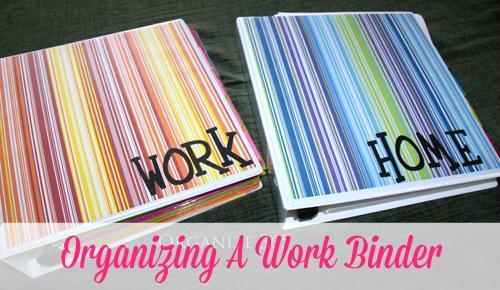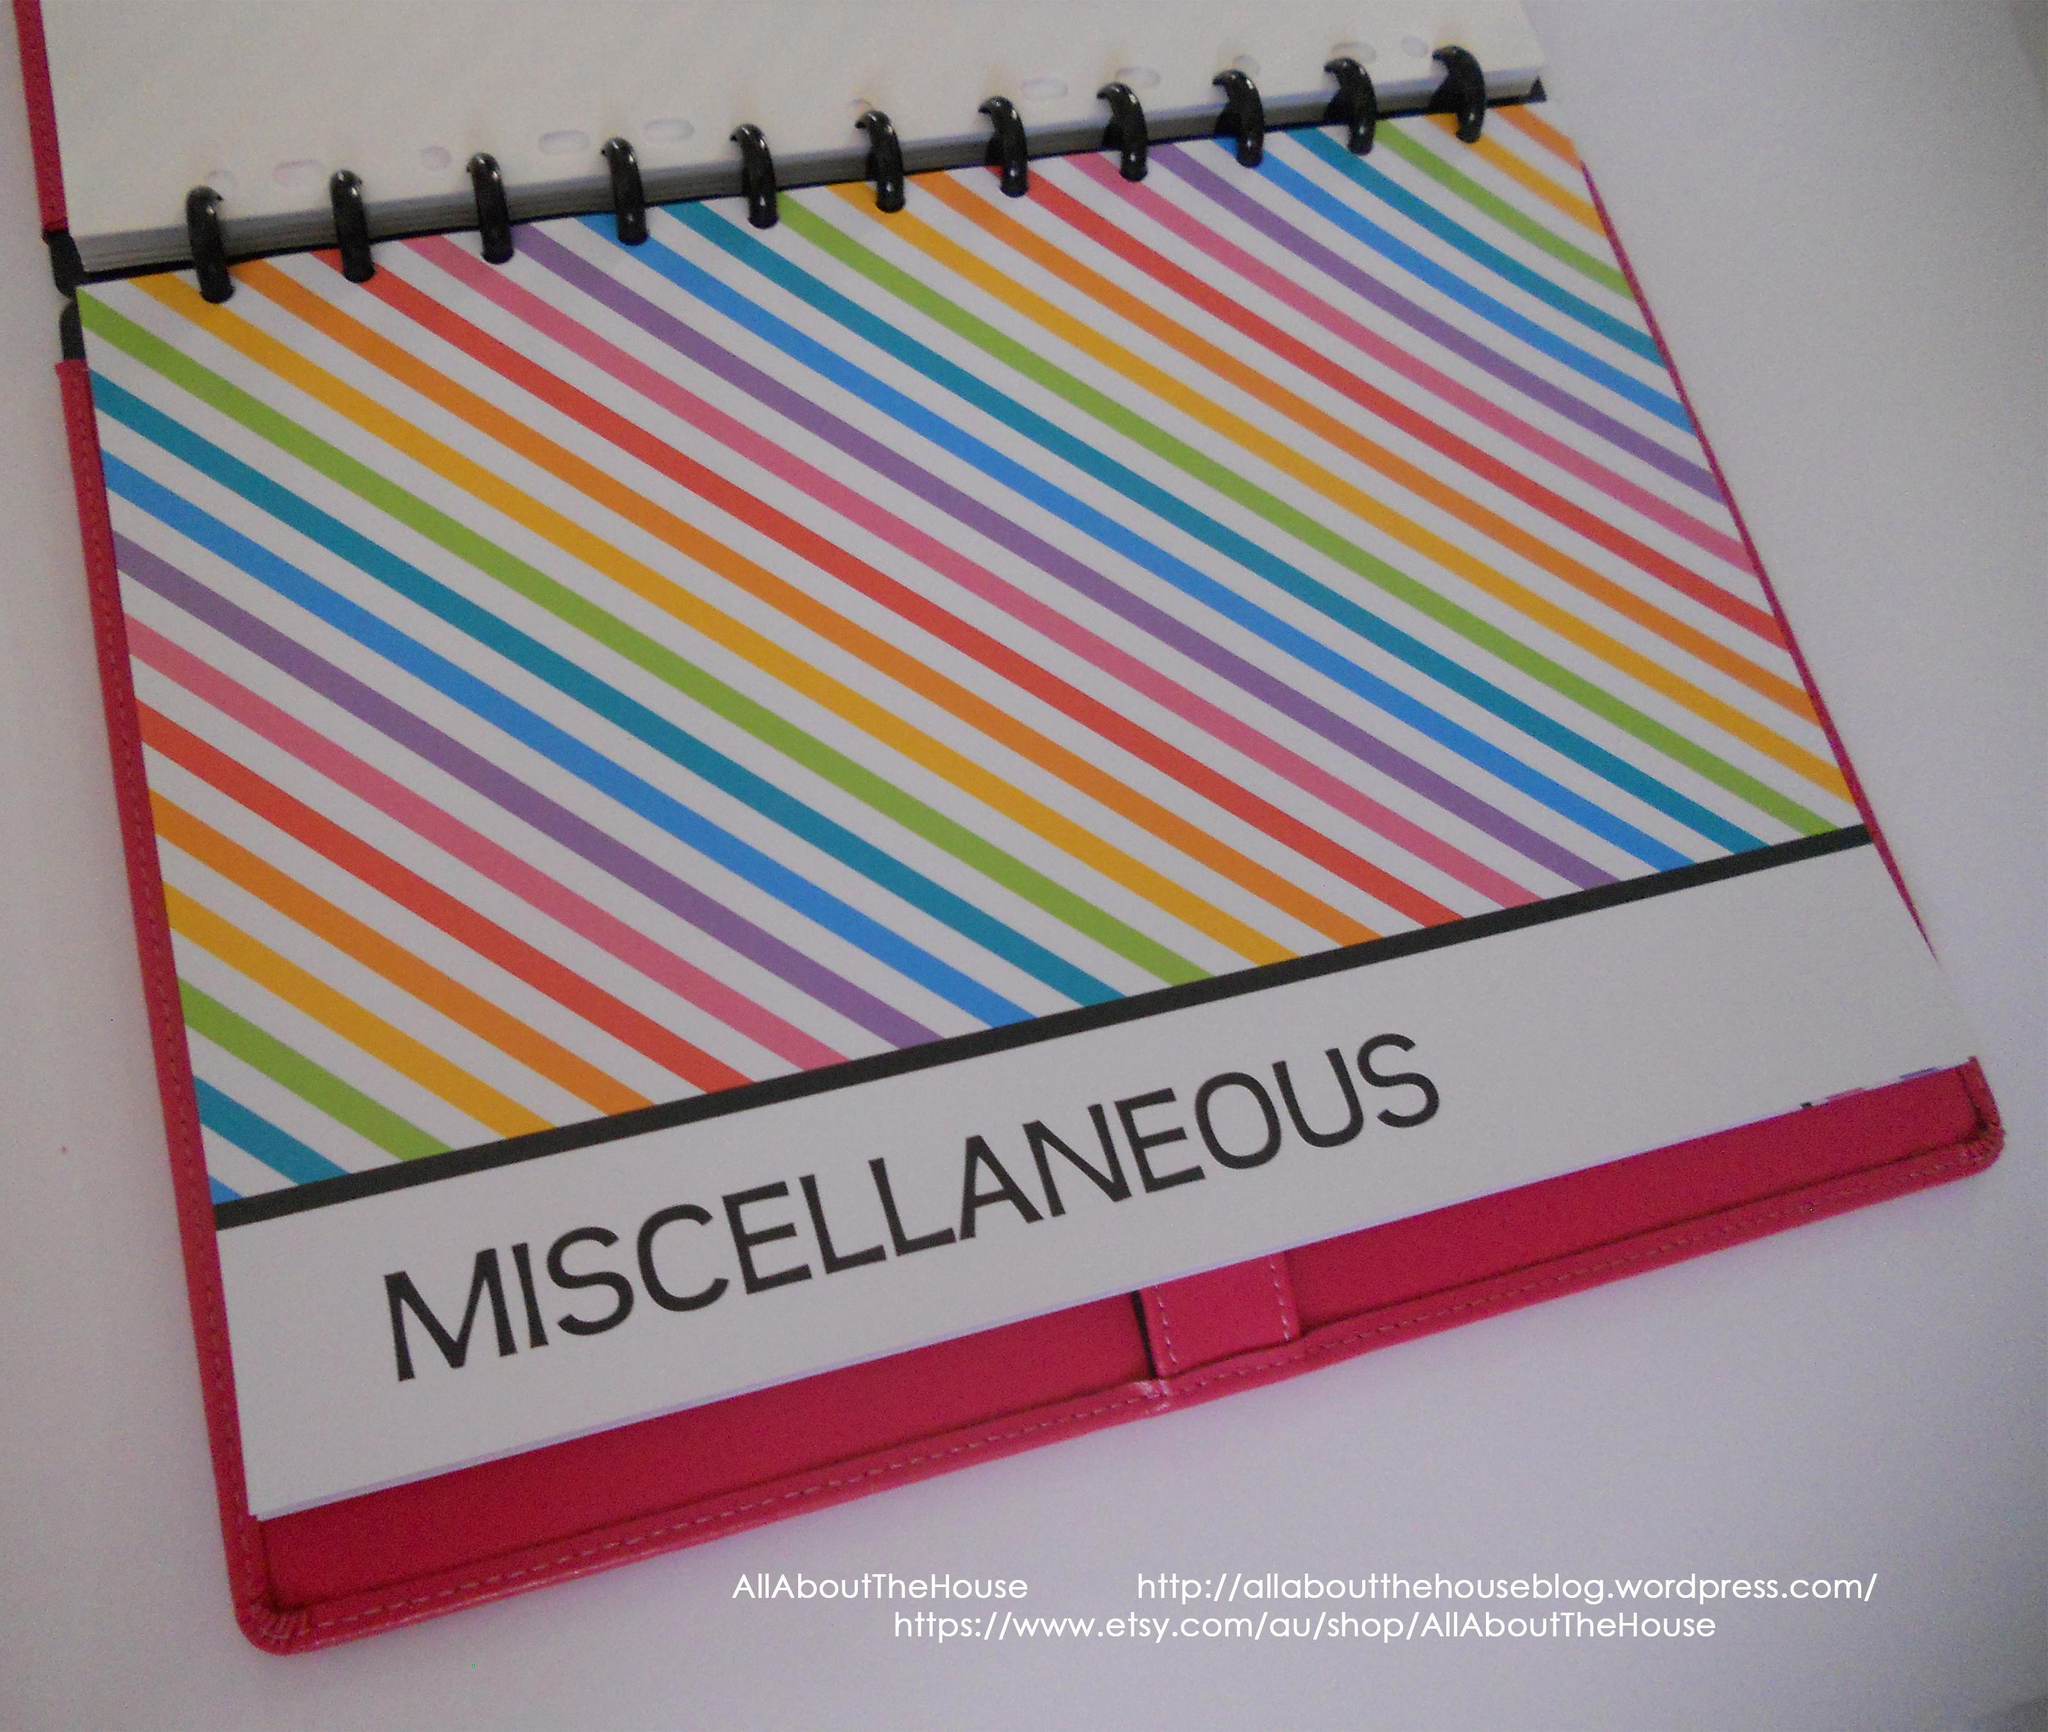The first image is the image on the left, the second image is the image on the right. Assess this claim about the two images: "At least one binder with pages in it is opened.". Correct or not? Answer yes or no. No. 